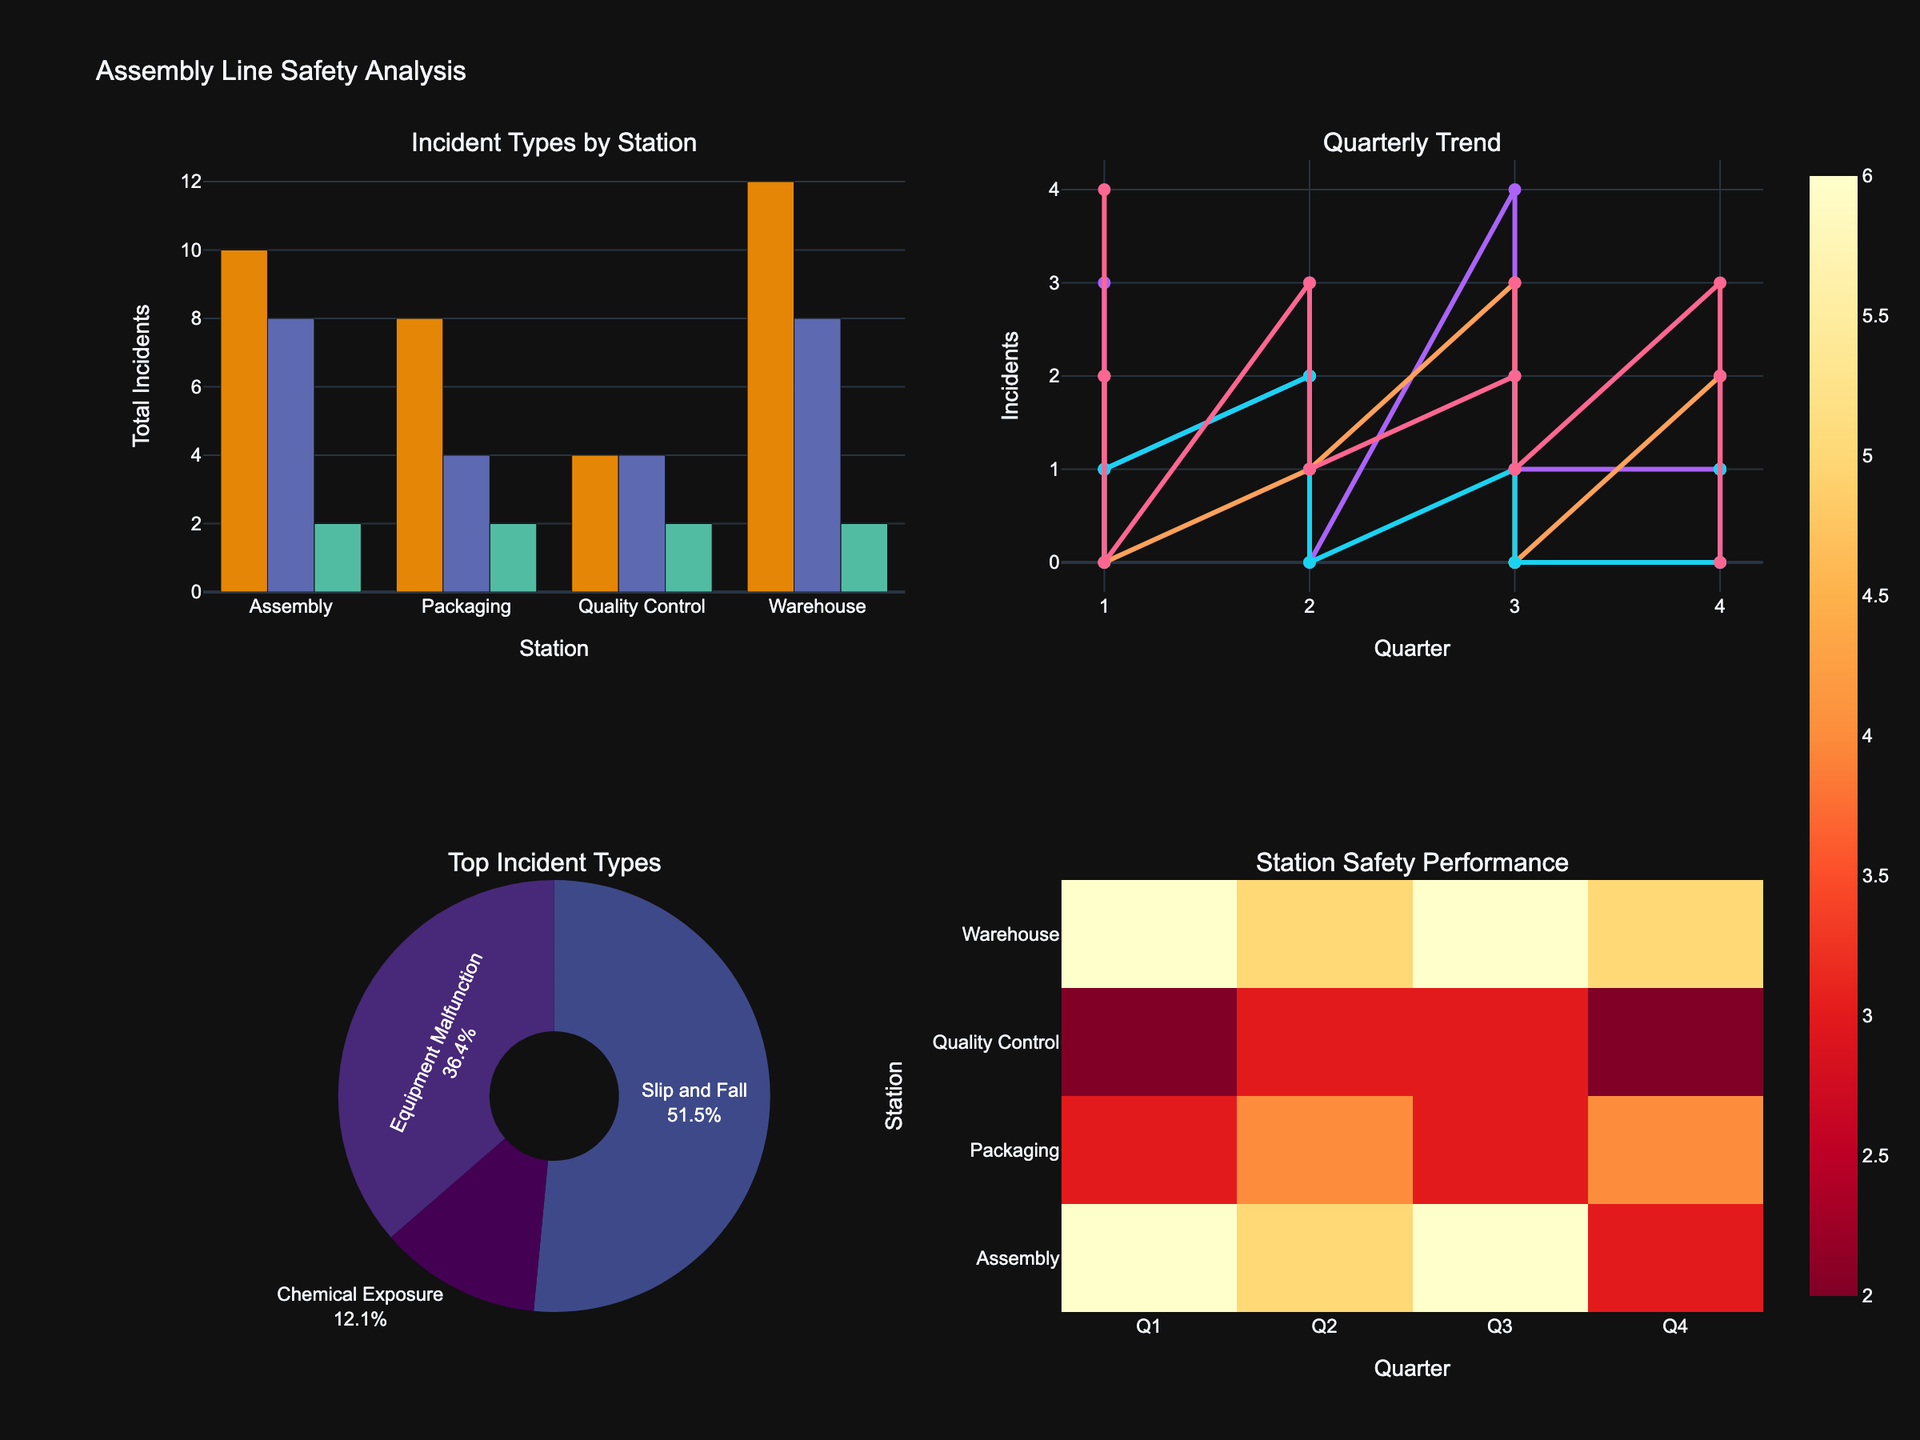What's the total number of Slip and Fall incidents in the Assembly line over the year? To find the total number of Slip and Fall incidents in the Assembly line, add up the incidents from quarters Q1 to Q4: 3 + 2 + 4 + 1 = 10.
Answer: 10 Which station had the highest number of Slip and Fall incidents in Q2? Compare the number of Slip and Fall incidents in Q2 across all stations: Assembly (2), Packaging (1), Quality Control (2), Warehouse (3). The highest number is in the Warehouse.
Answer: Warehouse What is the trend of incidents in the Warehouse over the quarters? Look at the scatter plot for the Warehouse station and observe the pattern of incident numbers across Q1 to Q4. The incidents in the Warehouse show variations but remain generally high: Q1 (6), Q2 (5), Q3 (6), Q4 (5).
Answer: Fluctuating Which Incident Type constitutes the largest percentage of the total incidents? Refer to the pie chart. The Incident Type with the largest percentage can be found by observing the slice with the largest size. Slip and Fall appears to be the largest.
Answer: Slip and Fall What station had the fewest total incidents across all quarters? Look at the bar chart and sum the total incidents for each station across all Incident Types and quarters. Quality Control appears to have fewer incidents compared to other stations.
Answer: Quality Control What is the difference in total number of Equipment Malfunction incidents between the Packaging and Warehouse stations? Sum the Equipment Malfunction incidents across all quarters for both stations: Packaging (1+2+0+1=4), Warehouse (2+1+3+2=8). The difference is 8 - 4 = 4.
Answer: 4 Which incident type shows the smallest number of incidents in Q3 across all stations? Observe the bar chart and find the incident types for Q3: Slip and Fall (10), Equipment Malfunction (6), Chemical Exposure (2). Chemical Exposure has the smallest number.
Answer: Chemical Exposure How does the trend of Slip and Fall incidents in Packaging compare to that in Quality Control? Observe the scatter plot trends for both stations. Packaging shows a variation (Q1: 2, Q2: 1, Q3: 3, Q4: 2) and Quality Control has a different pattern (Q1: 1, Q2: 2, Q3: 1, Q4: 0).
Answer: Different Which quarter had the highest total number of incidents across all stations? Look at the heat map and sum the incidents for each quarter across all stations: Q1 (15), Q2 (14), Q3 (14), Q4 (11). Q1 has the highest total.
Answer: Q1 